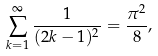<formula> <loc_0><loc_0><loc_500><loc_500>\sum _ { k = 1 } ^ { \infty } \frac { 1 } { ( 2 k - 1 ) ^ { 2 } } = \frac { \pi ^ { 2 } } { 8 } ,</formula> 